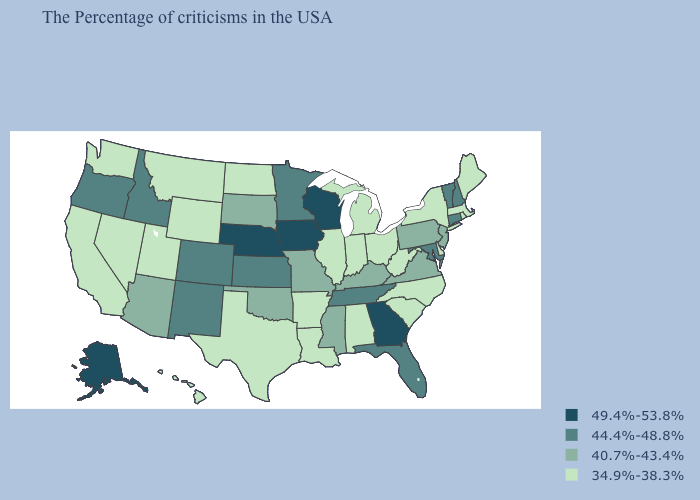Name the states that have a value in the range 49.4%-53.8%?
Short answer required. Georgia, Wisconsin, Iowa, Nebraska, Alaska. What is the highest value in the West ?
Short answer required. 49.4%-53.8%. What is the lowest value in the USA?
Quick response, please. 34.9%-38.3%. Does New Mexico have the lowest value in the USA?
Answer briefly. No. What is the value of Alaska?
Answer briefly. 49.4%-53.8%. Which states have the lowest value in the MidWest?
Answer briefly. Ohio, Michigan, Indiana, Illinois, North Dakota. How many symbols are there in the legend?
Short answer required. 4. Name the states that have a value in the range 44.4%-48.8%?
Quick response, please. New Hampshire, Vermont, Connecticut, Maryland, Florida, Tennessee, Minnesota, Kansas, Colorado, New Mexico, Idaho, Oregon. How many symbols are there in the legend?
Answer briefly. 4. Name the states that have a value in the range 40.7%-43.4%?
Concise answer only. New Jersey, Pennsylvania, Virginia, Kentucky, Mississippi, Missouri, Oklahoma, South Dakota, Arizona. Does the first symbol in the legend represent the smallest category?
Answer briefly. No. What is the value of New York?
Short answer required. 34.9%-38.3%. Name the states that have a value in the range 40.7%-43.4%?
Keep it brief. New Jersey, Pennsylvania, Virginia, Kentucky, Mississippi, Missouri, Oklahoma, South Dakota, Arizona. What is the highest value in the USA?
Quick response, please. 49.4%-53.8%. What is the value of Idaho?
Be succinct. 44.4%-48.8%. 